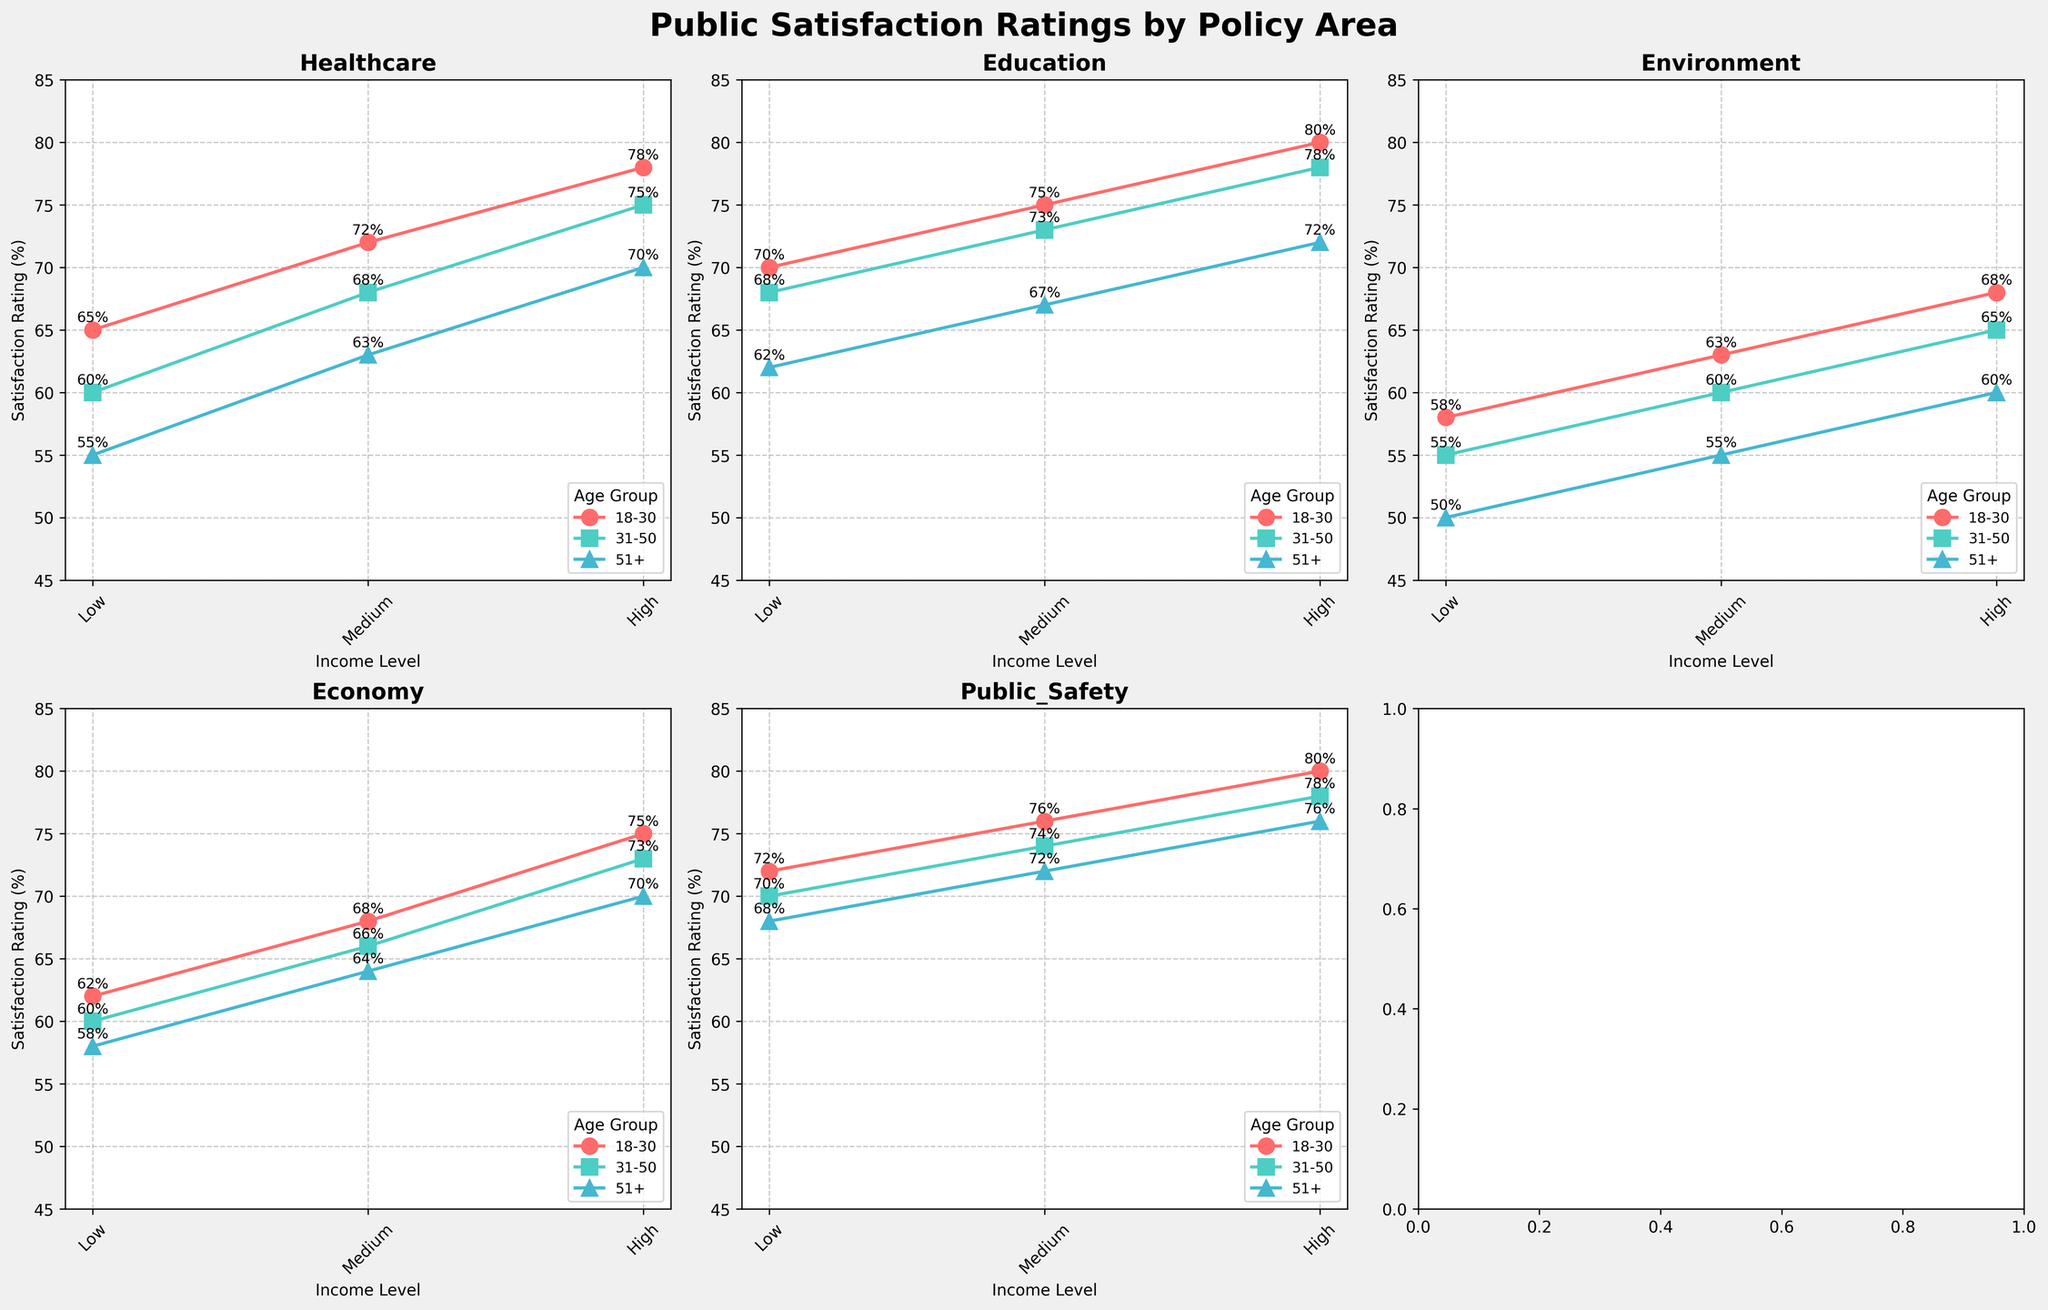Which age group has the highest satisfaction rating for healthcare among high-income individuals? Look at the plot for the healthcare policy. Among high-income individuals, compare satisfaction ratings for the age groups. The highest rating is observed for the 18-30 age group at 78%.
Answer: 18-30 Which policy has the lowest satisfaction rating for the 51+ age group amongst low-income individuals? Check each subplot for the 51+ age group and low-income individuals. The lowest rating is for the Environment policy at 50%.
Answer: Environment How does the satisfaction rating for low-income individuals in the 31-50 age group compare between public safety and healthcare? Look at the plots for Public Safety and Healthcare for the 31-50 age group and low income. Public Safety has a rating of 70% and Healthcare has a rating of 60%. Public Safety is higher by 10%.
Answer: Public Safety is 10% higher What is the average satisfaction rating for medium-income levels across all age groups in the Economy policy? For the Economy policy, gather medium-income satisfaction ratings: 68 (18-30), 66 (31-50), and 64 (51+). Calculate the average: (68 + 66 + 64) / 3 = 66.
Answer: 66 Which income level shows the most significant difference in satisfaction ratings between the 18-30 and 51+ age groups for Education? For the Education policy, compare the ratings for 18-30 and 51+ for each income level. Low-income has a difference of 8% (70% - 62%), medium-income has a difference of 8% (75% - 67%), and high-income has a difference of 8% (80% - 72%). All differences are equal.
Answer: All income levels In which policy does the 31-50 age group show the least variability in satisfaction ratings across different income levels? Look at the 31-50 age group ratings across income levels for each policy. The differences are: Healthcare (60-75), Education (68-78), Environment (55-65), Economy (60-73), and Public Safety (70-78). The smallest range is for the Environment policy (10% range).
Answer: Environment What is the difference in satisfaction ratings between the high-income and low-income groups for the 18-30 age group in the Economy policy? Look at the Economy plot for the 18-30 age group. High income is 75%, and low income is 62%. The difference is 75% - 62% = 13%.
Answer: 13% Which age group consistently has the highest satisfaction ratings for Public Safety across all income levels? Check the Public Safety plot for each age group across all income levels. The 18-30 age group has the highest ratings of 72%, 76%, and 80%, consistently higher in each income level.
Answer: 18-30 What is the sum of high-income satisfaction ratings across all age groups for the Healthcare policy? For Healthcare, high-income ratings: 78 (18-30), 75 (31-50), and 70 (51+). Sum them: 78 + 75 + 70 = 223.
Answer: 223 How does the medium-income satisfaction rating for the 31-50 age group in Education compare to the 51+ age group in Healthcare at the same income level? Medium-income ratings: Education (31-50) is 73%, Healthcare (51+) is 63%. Education (73%) is 10% higher than Healthcare (63%).
Answer: 10% higher in Education 